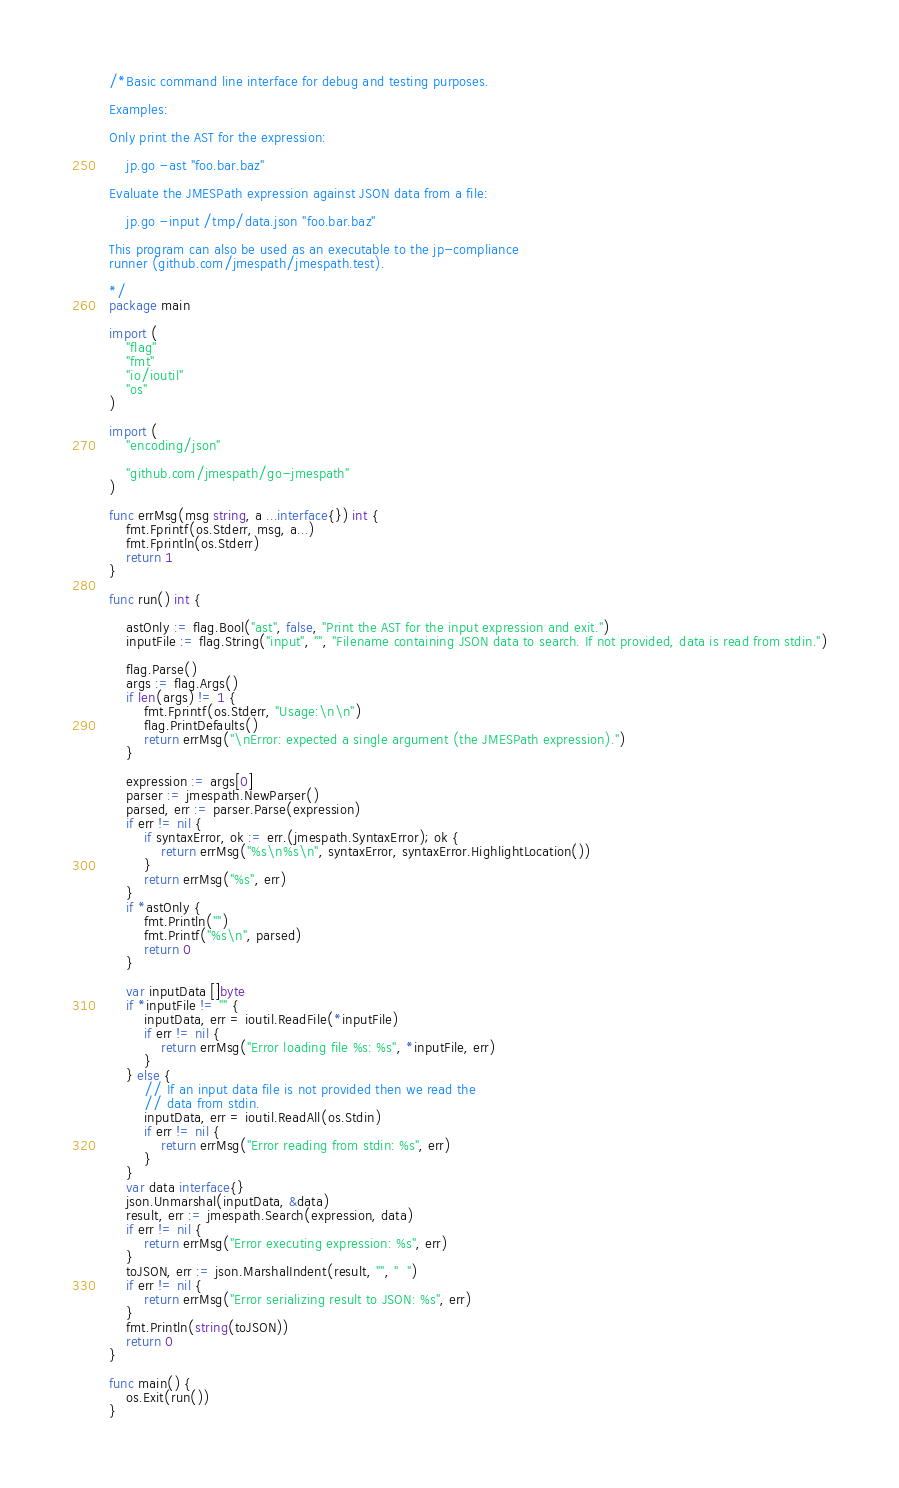<code> <loc_0><loc_0><loc_500><loc_500><_Go_>/*Basic command line interface for debug and testing purposes.

Examples:

Only print the AST for the expression:

    jp.go -ast "foo.bar.baz"

Evaluate the JMESPath expression against JSON data from a file:

    jp.go -input /tmp/data.json "foo.bar.baz"

This program can also be used as an executable to the jp-compliance
runner (github.com/jmespath/jmespath.test).

*/
package main

import (
	"flag"
	"fmt"
	"io/ioutil"
	"os"
)

import (
	"encoding/json"

	"github.com/jmespath/go-jmespath"
)

func errMsg(msg string, a ...interface{}) int {
	fmt.Fprintf(os.Stderr, msg, a...)
	fmt.Fprintln(os.Stderr)
	return 1
}

func run() int {

	astOnly := flag.Bool("ast", false, "Print the AST for the input expression and exit.")
	inputFile := flag.String("input", "", "Filename containing JSON data to search. If not provided, data is read from stdin.")

	flag.Parse()
	args := flag.Args()
	if len(args) != 1 {
		fmt.Fprintf(os.Stderr, "Usage:\n\n")
		flag.PrintDefaults()
		return errMsg("\nError: expected a single argument (the JMESPath expression).")
	}

	expression := args[0]
	parser := jmespath.NewParser()
	parsed, err := parser.Parse(expression)
	if err != nil {
		if syntaxError, ok := err.(jmespath.SyntaxError); ok {
			return errMsg("%s\n%s\n", syntaxError, syntaxError.HighlightLocation())
		}
		return errMsg("%s", err)
	}
	if *astOnly {
		fmt.Println("")
		fmt.Printf("%s\n", parsed)
		return 0
	}

	var inputData []byte
	if *inputFile != "" {
		inputData, err = ioutil.ReadFile(*inputFile)
		if err != nil {
			return errMsg("Error loading file %s: %s", *inputFile, err)
		}
	} else {
		// If an input data file is not provided then we read the
		// data from stdin.
		inputData, err = ioutil.ReadAll(os.Stdin)
		if err != nil {
			return errMsg("Error reading from stdin: %s", err)
		}
	}
	var data interface{}
	json.Unmarshal(inputData, &data)
	result, err := jmespath.Search(expression, data)
	if err != nil {
		return errMsg("Error executing expression: %s", err)
	}
	toJSON, err := json.MarshalIndent(result, "", "  ")
	if err != nil {
		return errMsg("Error serializing result to JSON: %s", err)
	}
	fmt.Println(string(toJSON))
	return 0
}

func main() {
	os.Exit(run())
}
</code> 